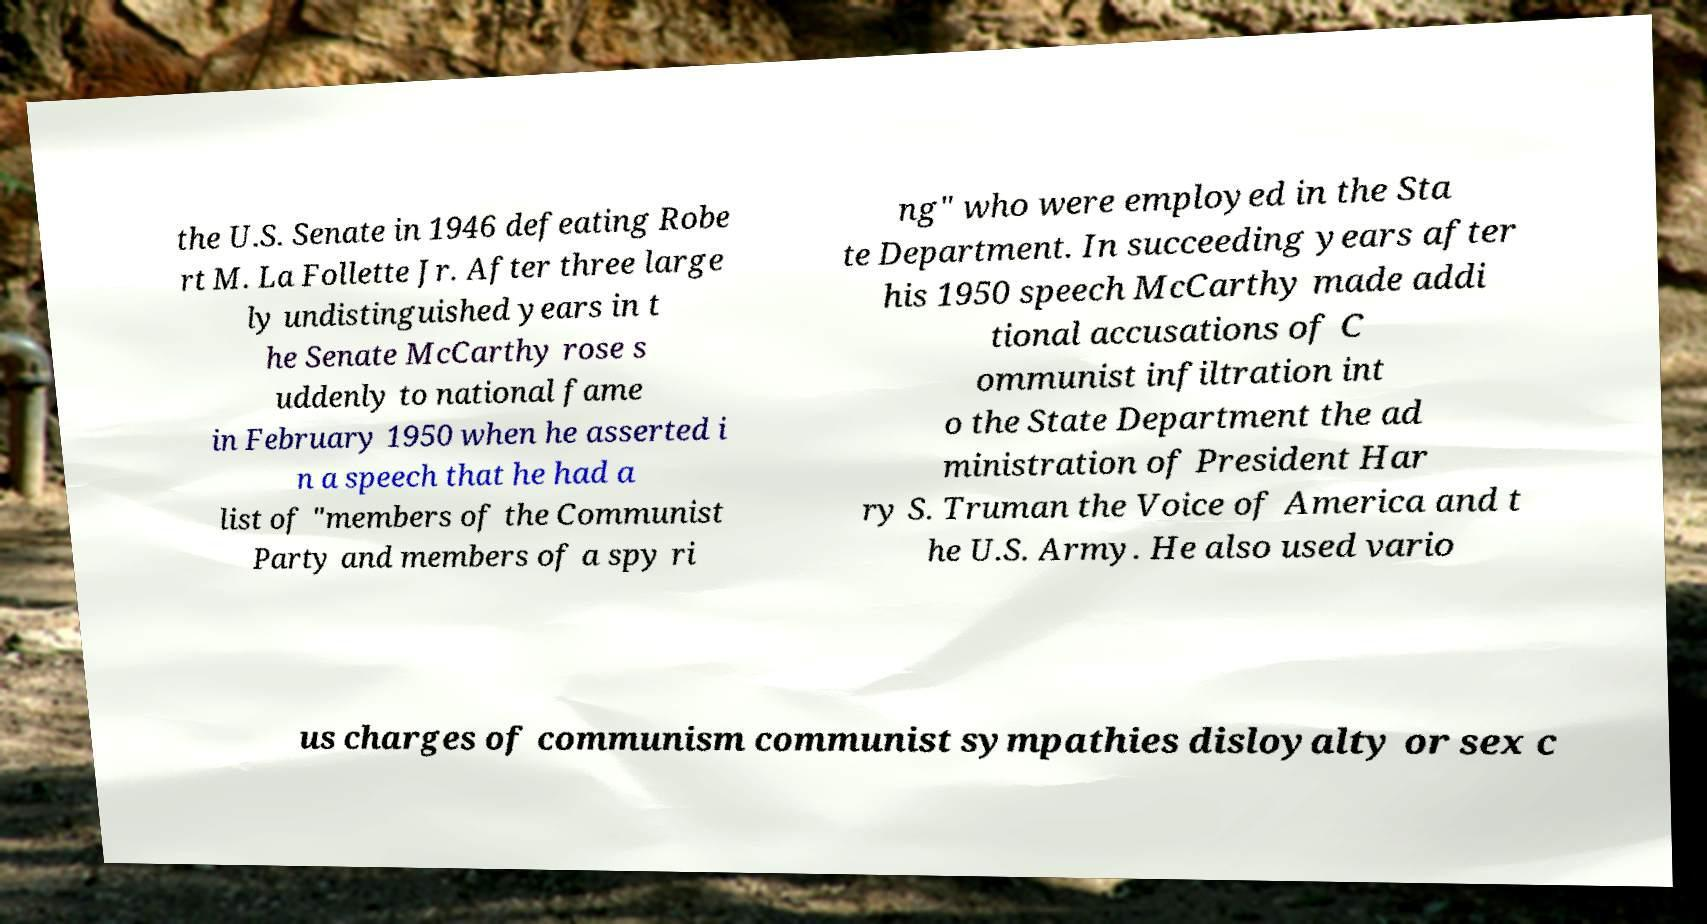Could you assist in decoding the text presented in this image and type it out clearly? the U.S. Senate in 1946 defeating Robe rt M. La Follette Jr. After three large ly undistinguished years in t he Senate McCarthy rose s uddenly to national fame in February 1950 when he asserted i n a speech that he had a list of "members of the Communist Party and members of a spy ri ng" who were employed in the Sta te Department. In succeeding years after his 1950 speech McCarthy made addi tional accusations of C ommunist infiltration int o the State Department the ad ministration of President Har ry S. Truman the Voice of America and t he U.S. Army. He also used vario us charges of communism communist sympathies disloyalty or sex c 